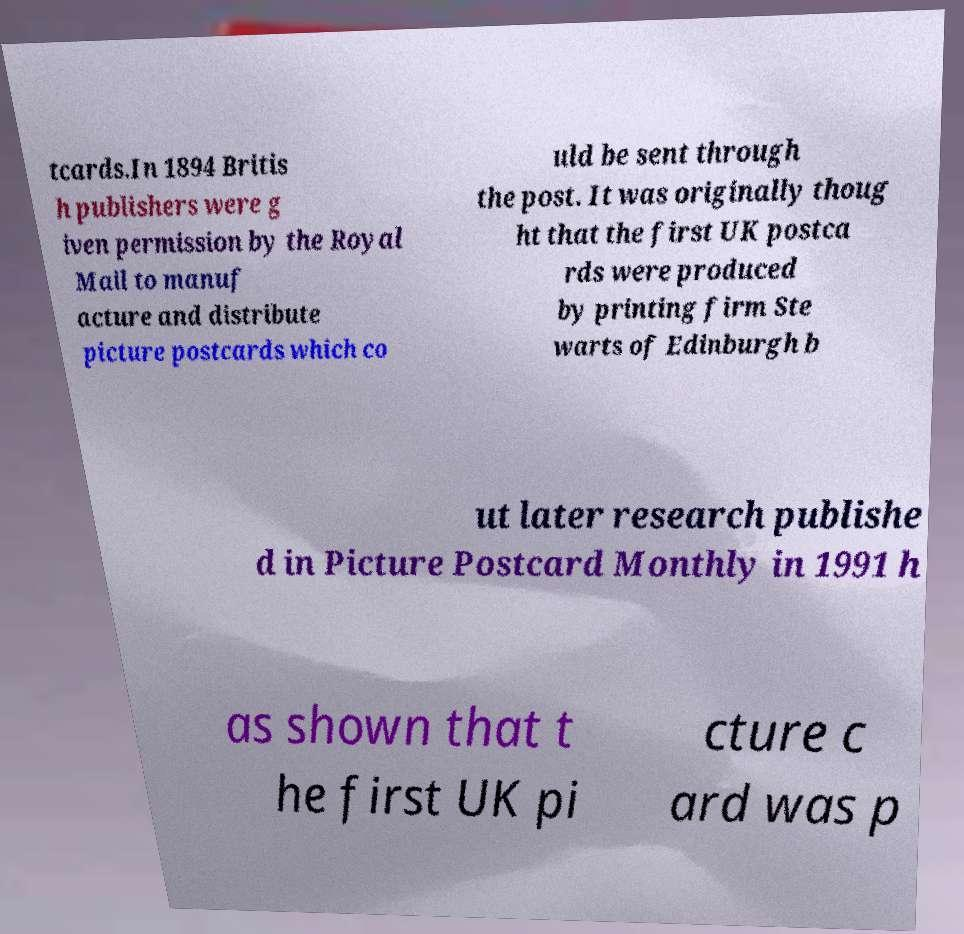I need the written content from this picture converted into text. Can you do that? tcards.In 1894 Britis h publishers were g iven permission by the Royal Mail to manuf acture and distribute picture postcards which co uld be sent through the post. It was originally thoug ht that the first UK postca rds were produced by printing firm Ste warts of Edinburgh b ut later research publishe d in Picture Postcard Monthly in 1991 h as shown that t he first UK pi cture c ard was p 